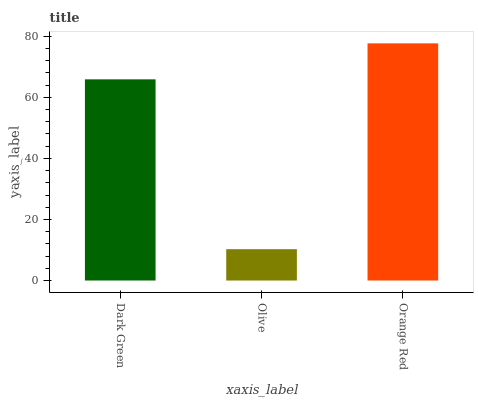Is Olive the minimum?
Answer yes or no. Yes. Is Orange Red the maximum?
Answer yes or no. Yes. Is Orange Red the minimum?
Answer yes or no. No. Is Olive the maximum?
Answer yes or no. No. Is Orange Red greater than Olive?
Answer yes or no. Yes. Is Olive less than Orange Red?
Answer yes or no. Yes. Is Olive greater than Orange Red?
Answer yes or no. No. Is Orange Red less than Olive?
Answer yes or no. No. Is Dark Green the high median?
Answer yes or no. Yes. Is Dark Green the low median?
Answer yes or no. Yes. Is Olive the high median?
Answer yes or no. No. Is Olive the low median?
Answer yes or no. No. 